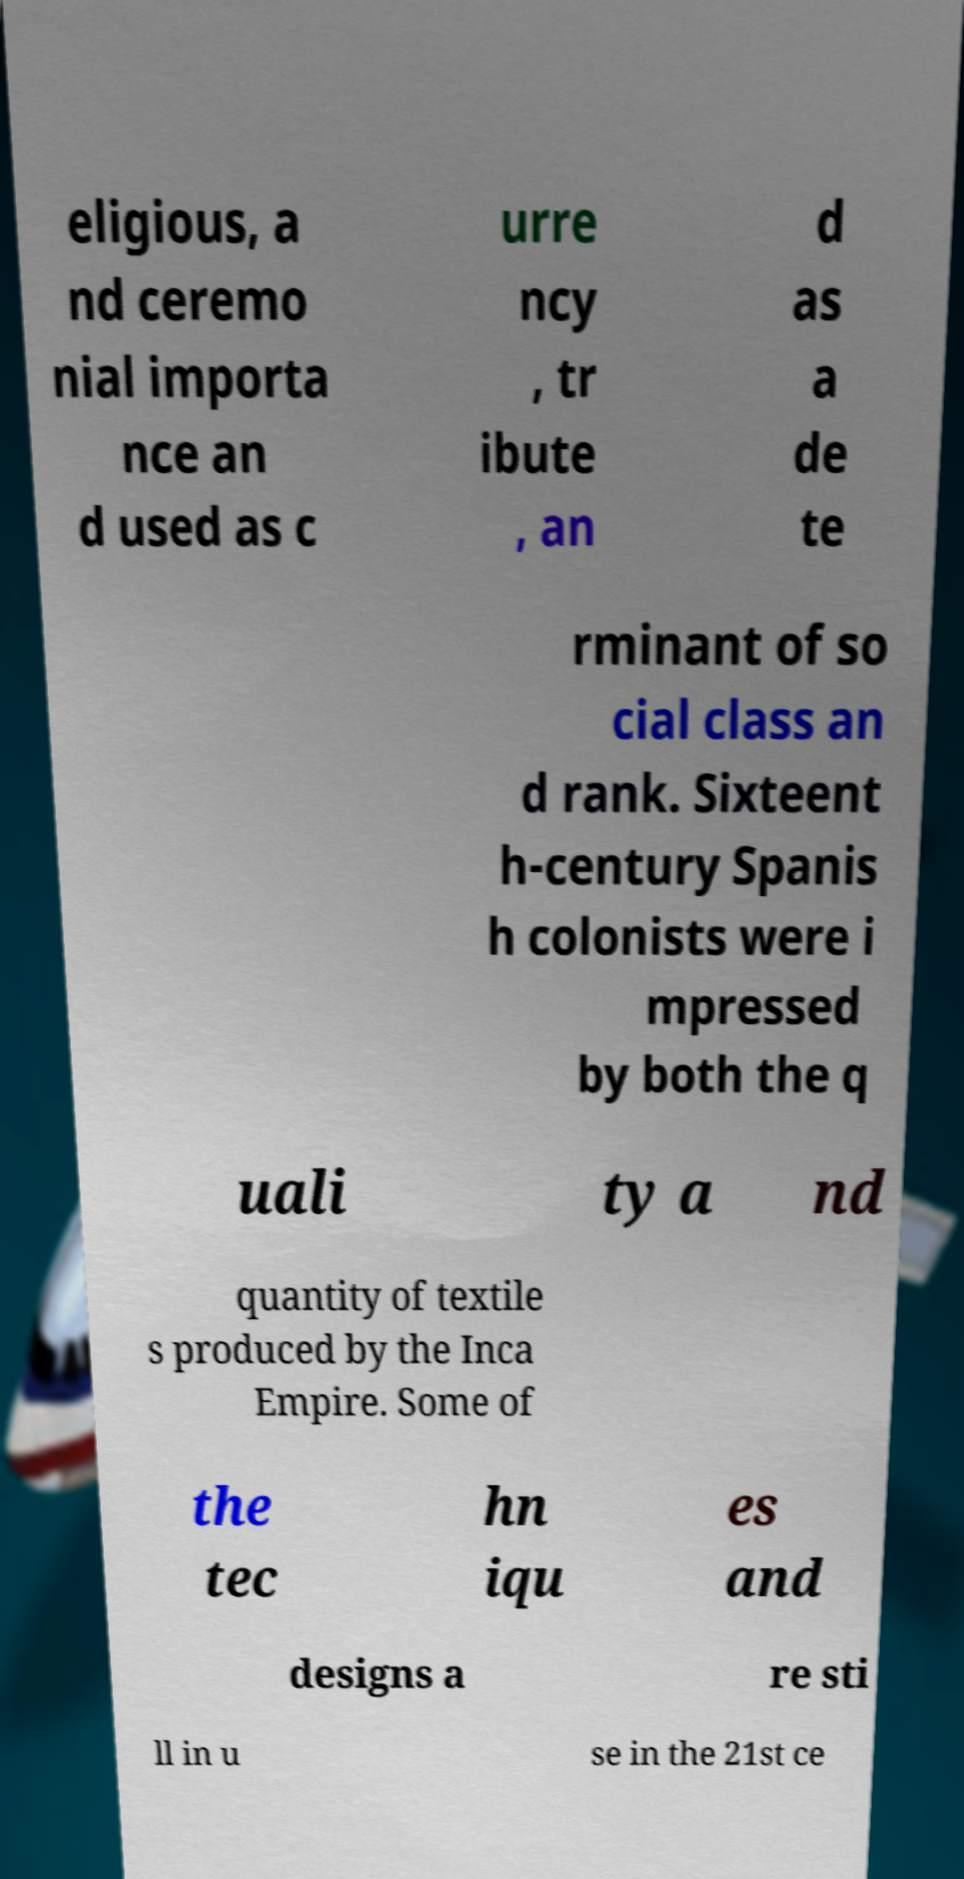For documentation purposes, I need the text within this image transcribed. Could you provide that? eligious, a nd ceremo nial importa nce an d used as c urre ncy , tr ibute , an d as a de te rminant of so cial class an d rank. Sixteent h-century Spanis h colonists were i mpressed by both the q uali ty a nd quantity of textile s produced by the Inca Empire. Some of the tec hn iqu es and designs a re sti ll in u se in the 21st ce 